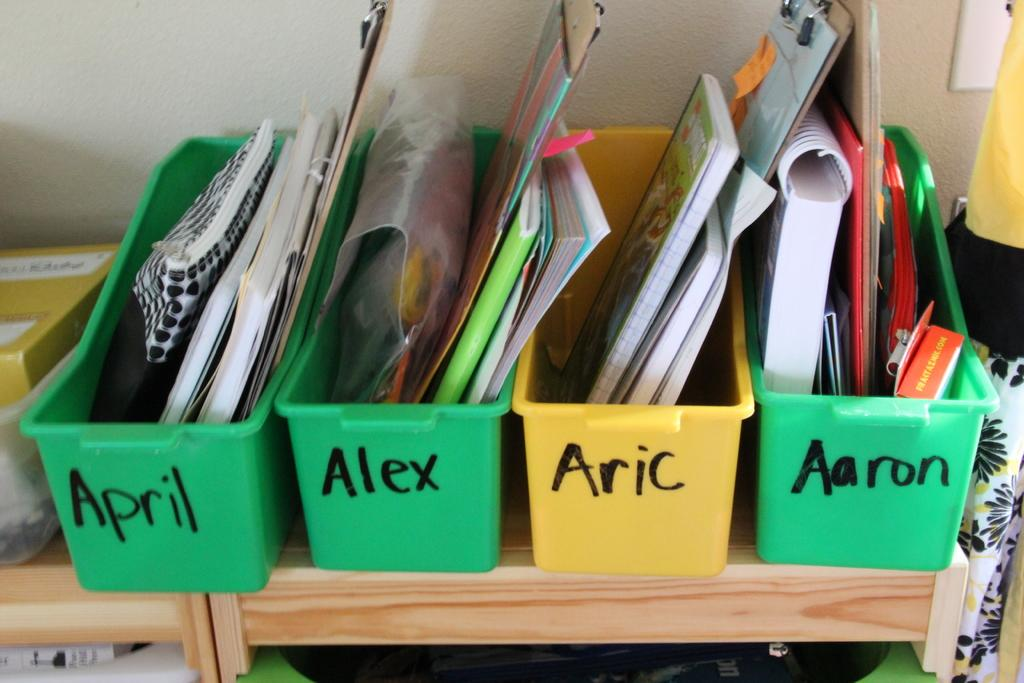Provide a one-sentence caption for the provided image. Four school supplies containers with names written on them, all of which start with the letter "A". 